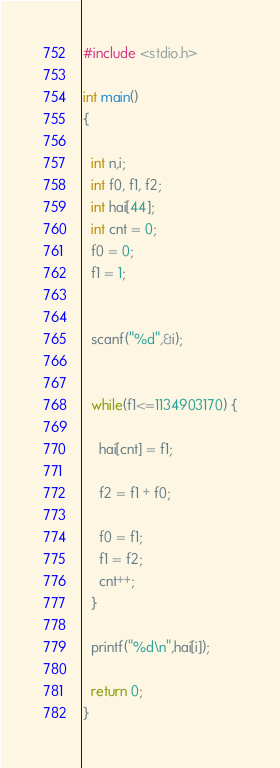Convert code to text. <code><loc_0><loc_0><loc_500><loc_500><_C_>#include <stdio.h>
 
int main()
{
 
  int n,i;
  int f0, f1, f2;
  int hai[44];
  int cnt = 0;
  f0 = 0;
  f1 = 1;
 
 
  scanf("%d",&i);
 
 
  while(f1<=1134903170) {
    
    hai[cnt] = f1;
    
    f2 = f1 + f0;
   
    f0 = f1;
    f1 = f2;
    cnt++;
  }

  printf("%d\n",hai[i]);
 
  return 0;
}

</code> 